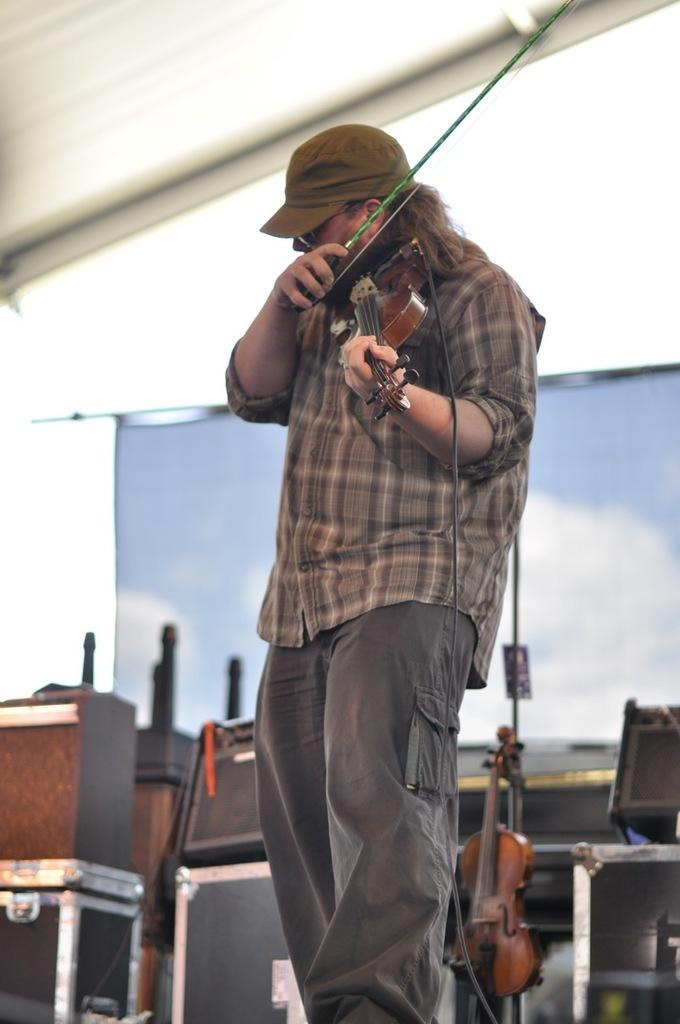What is the man in the image doing? The man is playing the violin. What instrument is the man holding in the image? The man is holding a violin. Are there any other objects related to the violin in the image? Yes, there is a violin in the background of the image. What can be seen in the background of the image? There are other objects in the background of the image, including a violin. What is the aftermath of the pot in the image? There is no pot present in the image, so it is not possible to discuss the aftermath of a pot. 